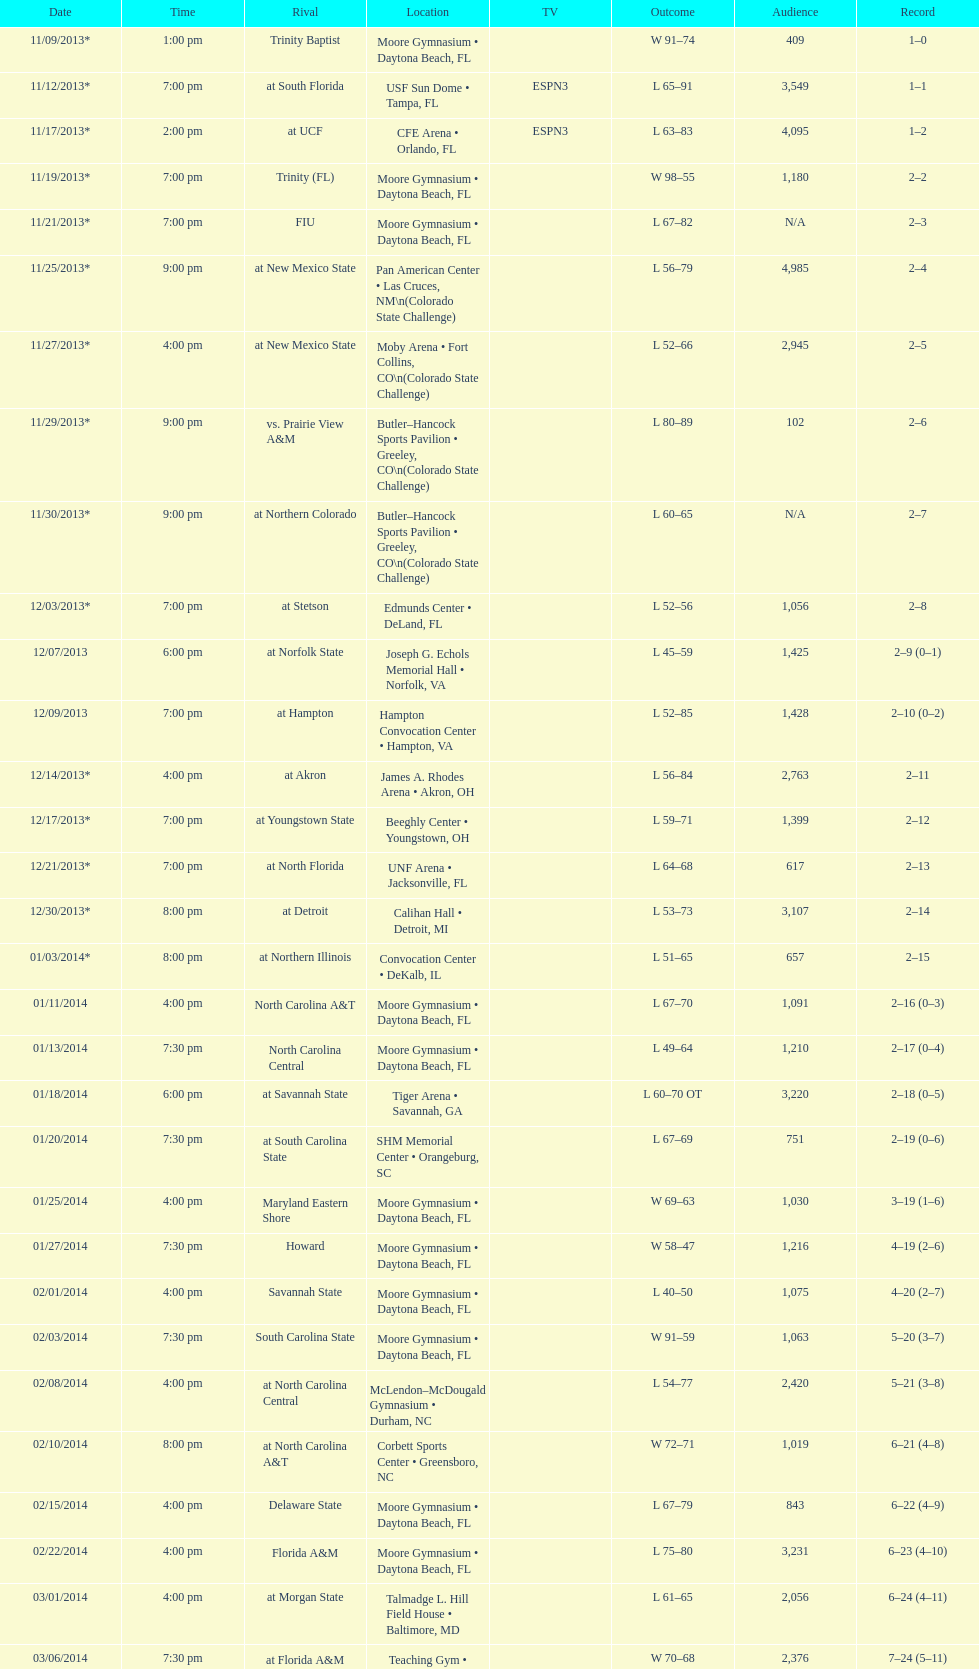What is the total attendance on 11/09/2013? 409. 